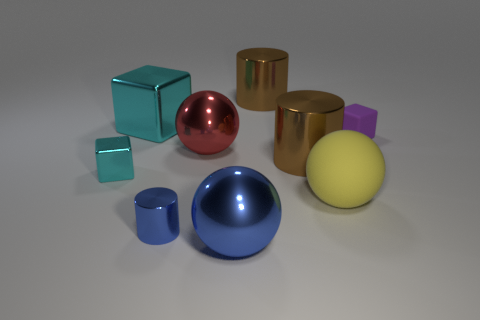Is the color of the tiny matte cube the same as the tiny metallic block?
Give a very brief answer. No. How many other objects are there of the same material as the purple object?
Ensure brevity in your answer.  1. There is a rubber object that is behind the big rubber thing; is its color the same as the big rubber sphere?
Your answer should be very brief. No. How many rubber things are either big brown things or tiny purple objects?
Provide a short and direct response. 1. Are there any other things that have the same size as the rubber block?
Ensure brevity in your answer.  Yes. There is a large cube that is the same material as the red object; what is its color?
Make the answer very short. Cyan. What number of blocks are matte things or small cyan metal things?
Your response must be concise. 2. How many things are tiny blue shiny cylinders or things in front of the big cyan metal thing?
Provide a succinct answer. 7. Are any yellow matte objects visible?
Provide a short and direct response. Yes. How many matte objects have the same color as the small metallic block?
Your response must be concise. 0. 